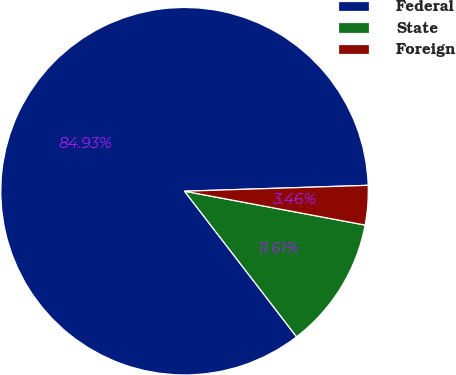Convert chart to OTSL. <chart><loc_0><loc_0><loc_500><loc_500><pie_chart><fcel>Federal<fcel>State<fcel>Foreign<nl><fcel>84.93%<fcel>11.61%<fcel>3.46%<nl></chart> 